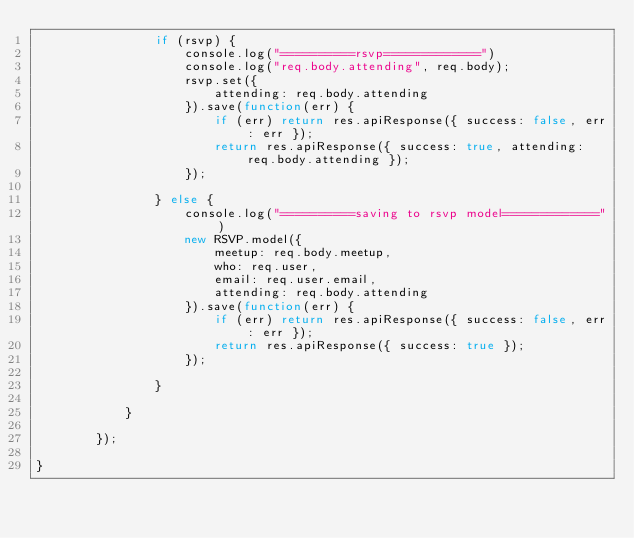Convert code to text. <code><loc_0><loc_0><loc_500><loc_500><_JavaScript_>				if (rsvp) {
					console.log("==========rsvp=============")
					console.log("req.body.attending", req.body);
					rsvp.set({
						attending: req.body.attending
					}).save(function(err) {
						if (err) return res.apiResponse({ success: false, err: err });
						return res.apiResponse({ success: true, attending: req.body.attending });
					});
				
				} else {
					console.log("==========saving to rsvp model=============")
					new RSVP.model({
						meetup: req.body.meetup,
						who: req.user,
						email: req.user.email,
						attending: req.body.attending
					}).save(function(err) {
						if (err) return res.apiResponse({ success: false, err: err });
						return res.apiResponse({ success: true });
					});
				
				}
				
			}
		
		});

}
</code> 